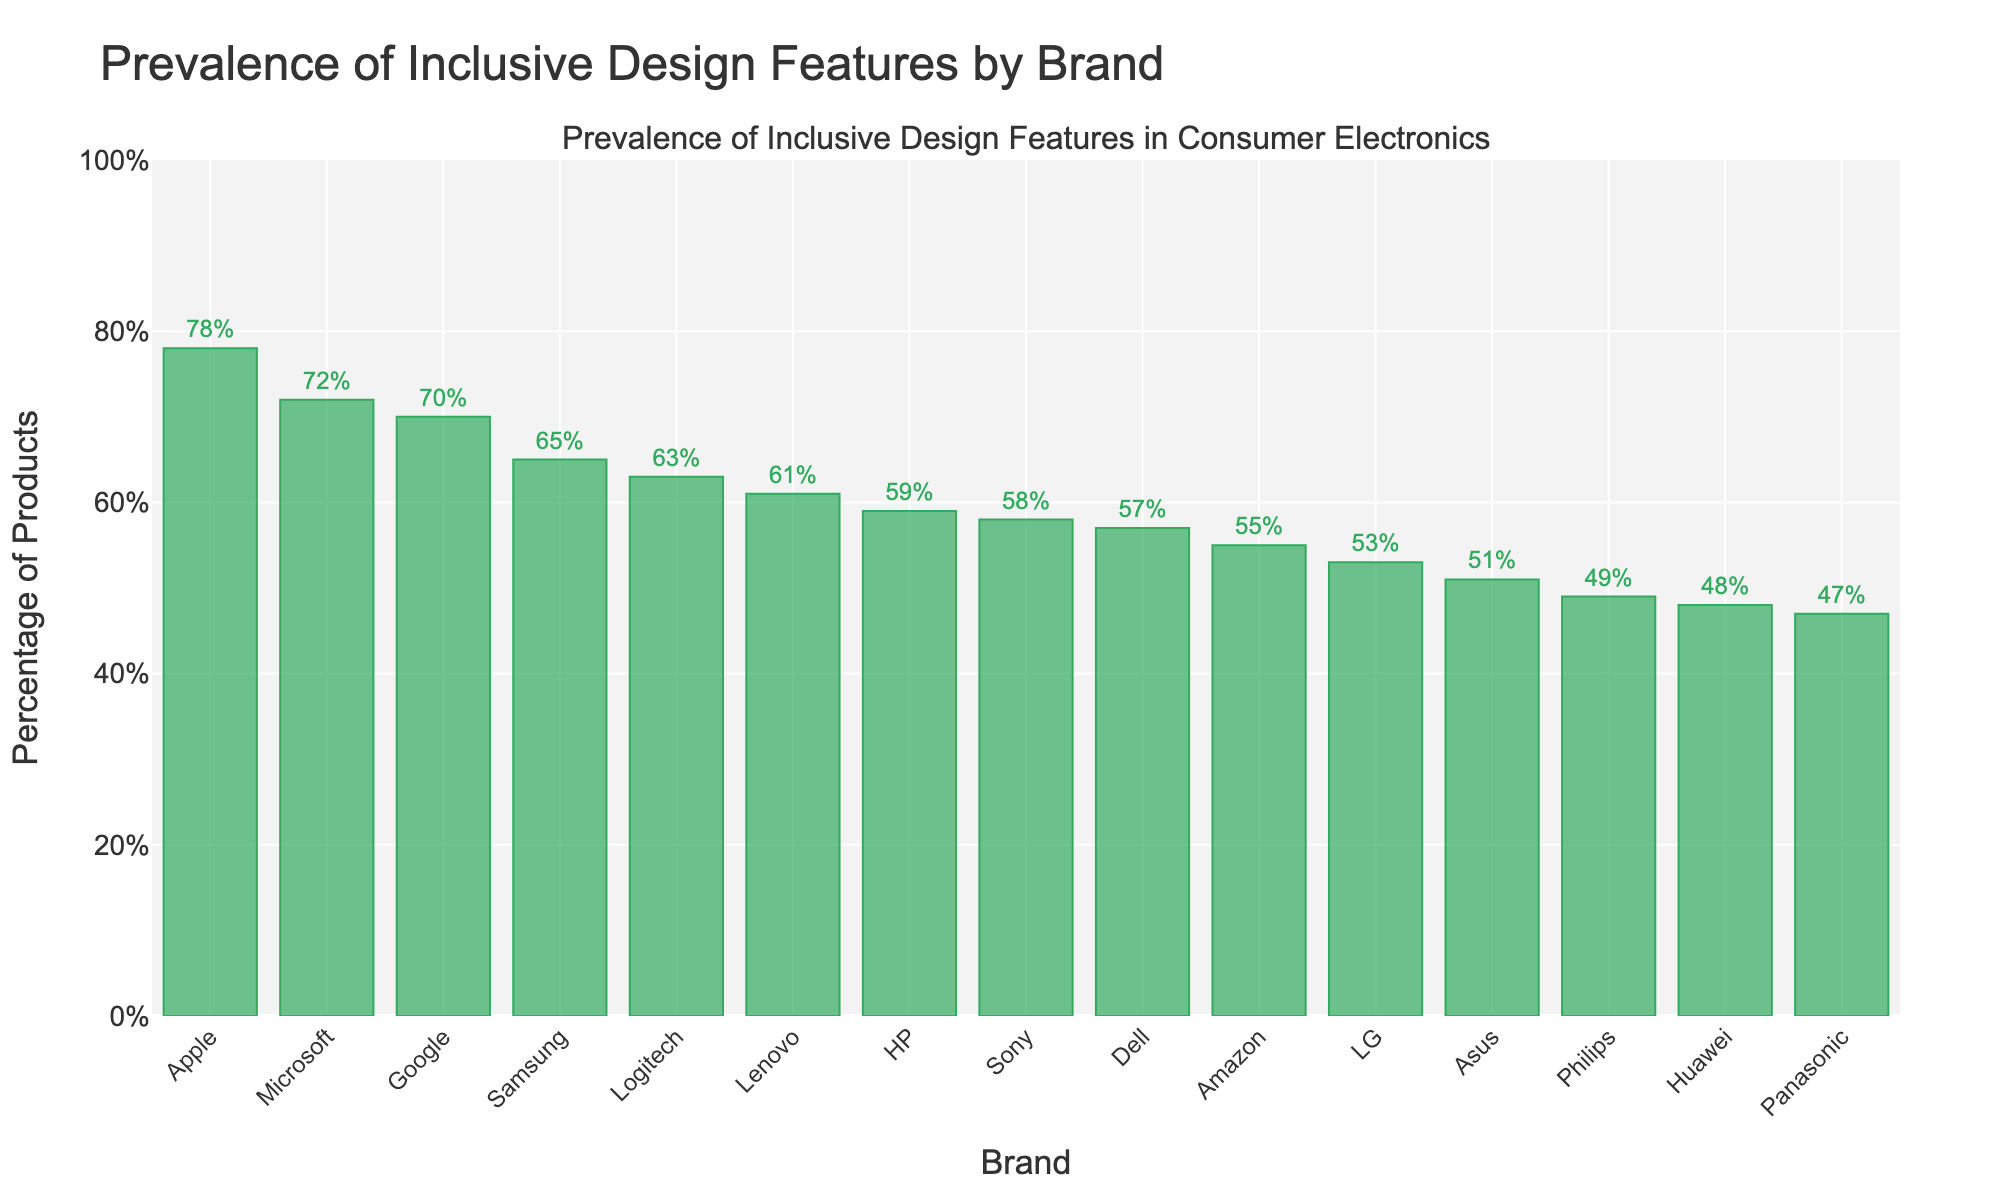What's the brand with the highest percentage of products with inclusive design features? The bar chart displays the percentage of products with inclusive design features. Observing the heights of the bars, Apple has the tallest bar at 78%.
Answer: Apple Which brands have a percentage of products with inclusive design features above 70%? We need to identify bars in the chart that exceed the 70% mark. Apple (78%), Microsoft (72%), and Google (70%) are above this threshold.
Answer: Apple, Microsoft, Google What is the range of the percentages of inclusive design features among all brands? The range is calculated by finding the difference between the maximum and minimum values. Apple has the highest at 78%, and Panasonic has the lowest at 47%. The range is 78% - 47% = 31%.
Answer: 31% Which brand has a higher percentage of inclusive design features, Sony or Lenovo? Comparing the heights of the bars for Sony and Lenovo, Sony has 58% while Lenovo has 61%. Therefore, Lenovo has a higher percentage.
Answer: Lenovo What's the difference in percentage of products with inclusive design features between the top and bottom-ranked brands? The top-ranked brand is Apple at 78%, and the bottom-ranked brand is Panasonic at 47%. The difference is calculated as 78% - 47% = 31%.
Answer: 31% How many brands have a percentage of products with inclusive design features greater than 60%? Identify the bars in the chart that are above the 60% line. The brands are Apple (78%), Samsung (65%), Microsoft (72%), Google (70%), Lenovo (61%), and Logitech (63%). There are 6 brands in total.
Answer: 6 What is the median percentage of products with inclusive design features? To find the median, sort the percentages in ascending order and locate the middle value. The sorted percentages are: 47, 48, 49, 51, 53, 55, 57, 58, 59, 61, 63, 65, 70, 72, 78. The middle value, or the 8th value, is 58%.
Answer: 58% Between Dell and Amazon, which brand has a lower percentage of products with inclusive design features? By comparing the heights of the bars for Dell (57%) and Amazon (55%), Amazon has a lower percentage.
Answer: Amazon What's the average percentage of products with inclusive design features for all brands? Sum all the percentages and divide by the number of brands: (78 + 65 + 72 + 70 + 58 + 53 + 61 + 59 + 57 + 63 + 55 + 49 + 47 + 51 + 48) / 15. The sum is 887, and the average is 887 / 15 ≈ 59.13%.
Answer: 59.13% Is the percentage of products with inclusive design features higher in HP or LG? Checking the bars for HP (59%) and LG (53%), HP has a higher percentage.
Answer: HP 